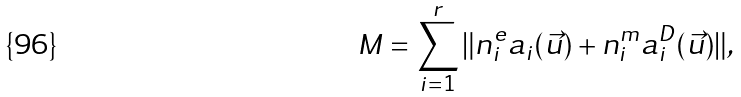Convert formula to latex. <formula><loc_0><loc_0><loc_500><loc_500>M = \sum _ { i = 1 } ^ { r } \| n _ { i } ^ { e } a _ { i } ( \vec { u } ) + n _ { i } ^ { m } a _ { i } ^ { D } ( \vec { u } ) \| ,</formula> 